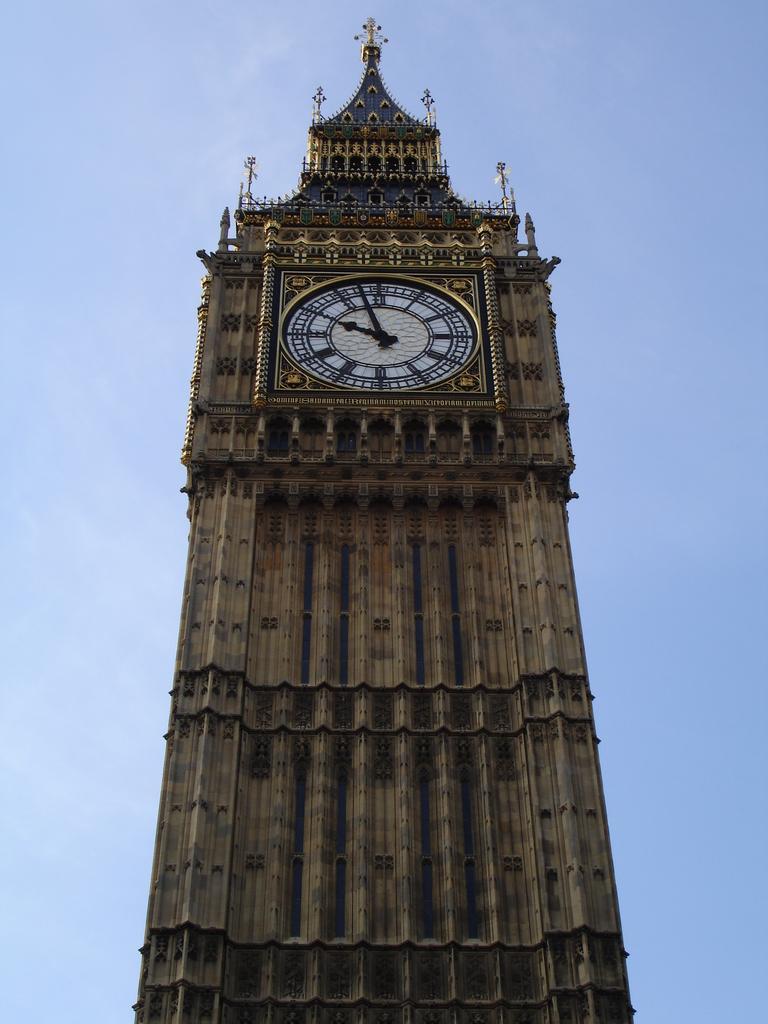Describe this image in one or two sentences. There is a large tower with a clock on it. It might be called as clock tower. In the background we can observe a sky here. 